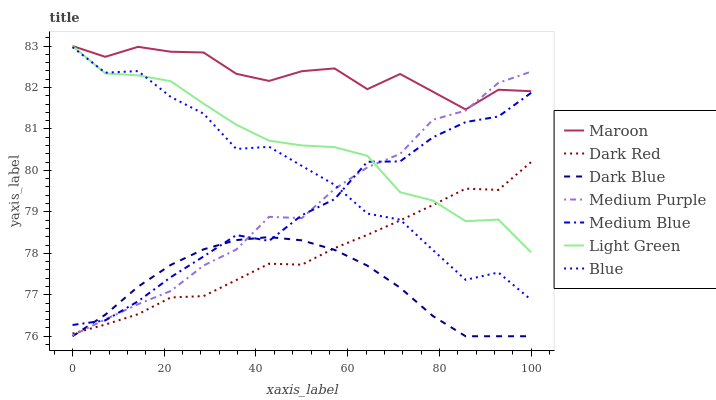Does Dark Blue have the minimum area under the curve?
Answer yes or no. Yes. Does Maroon have the maximum area under the curve?
Answer yes or no. Yes. Does Dark Red have the minimum area under the curve?
Answer yes or no. No. Does Dark Red have the maximum area under the curve?
Answer yes or no. No. Is Dark Blue the smoothest?
Answer yes or no. Yes. Is Blue the roughest?
Answer yes or no. Yes. Is Dark Red the smoothest?
Answer yes or no. No. Is Dark Red the roughest?
Answer yes or no. No. Does Dark Blue have the lowest value?
Answer yes or no. Yes. Does Dark Red have the lowest value?
Answer yes or no. No. Does Light Green have the highest value?
Answer yes or no. Yes. Does Dark Red have the highest value?
Answer yes or no. No. Is Dark Blue less than Light Green?
Answer yes or no. Yes. Is Maroon greater than Medium Blue?
Answer yes or no. Yes. Does Maroon intersect Medium Purple?
Answer yes or no. Yes. Is Maroon less than Medium Purple?
Answer yes or no. No. Is Maroon greater than Medium Purple?
Answer yes or no. No. Does Dark Blue intersect Light Green?
Answer yes or no. No. 